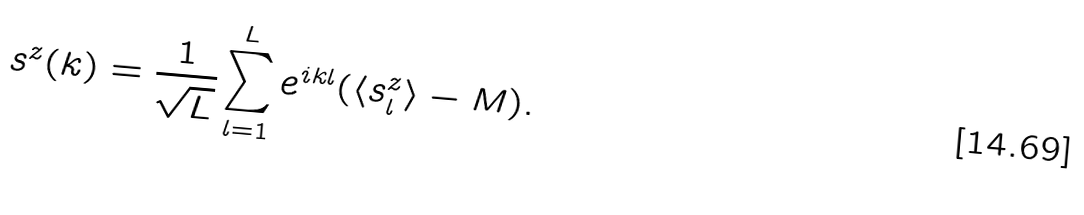Convert formula to latex. <formula><loc_0><loc_0><loc_500><loc_500>s ^ { z } ( k ) = \frac { 1 } { \sqrt { L } } \sum ^ { L } _ { l = 1 } e ^ { i k l } ( \langle s ^ { z } _ { l } \rangle - M ) .</formula> 